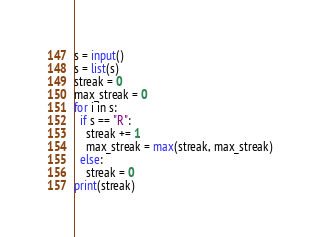<code> <loc_0><loc_0><loc_500><loc_500><_Python_>s = input()
s = list(s)
streak = 0
max_streak = 0
for i in s:
  if s == "R":
    streak += 1
    max_streak = max(streak, max_streak)
  else:
    streak = 0
print(streak)</code> 